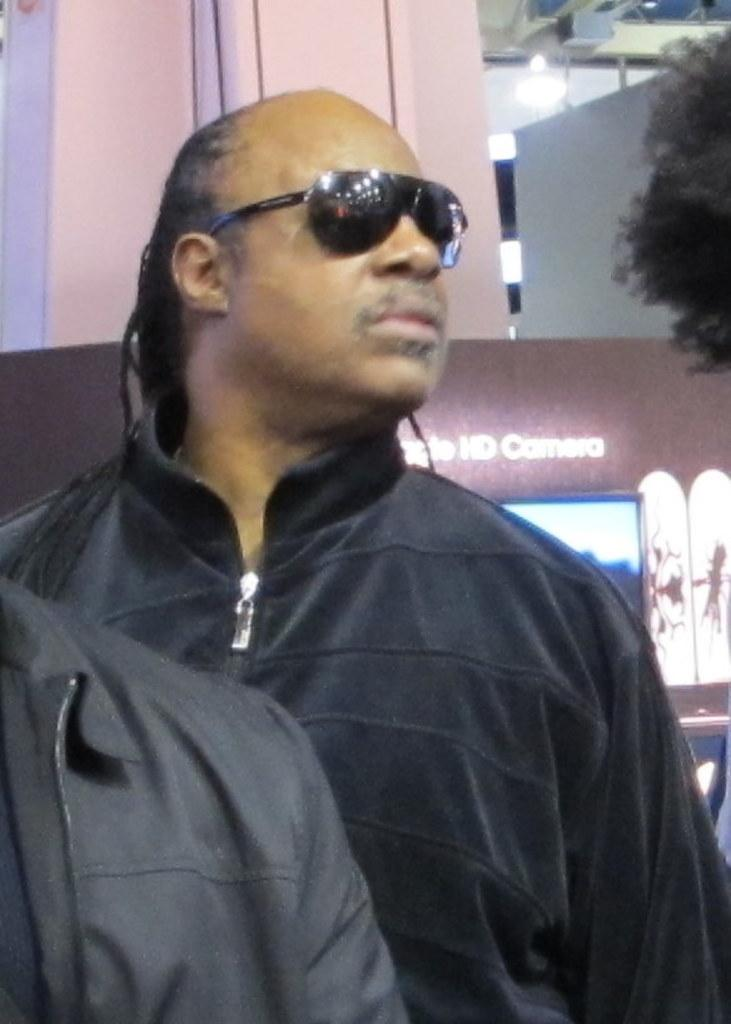Who can be seen in the image? There are people in the image. Can you describe the appearance of one of the individuals? A man is wearing spectacles. What can be seen in the distance behind the people? There is a building, lights, and a tree visible in the background of the image. What type of pleasure can be seen being enjoyed by the people in the image? There is no indication of pleasure or any specific activity being enjoyed by the people in the image. --- Facts: 1. There is a car in the image. 2. The car is red. 3. The car has four wheels. 4. There are people in the car. 5. The car is parked on the street. Absurd Topics: parrot, ocean, dance Conversation: What is the main subject of the image? The main subject of the image is a car. Can you describe the appearance of the car? The car is red and has four wheels. Who or what can be seen inside the car? There are people in the car. Where is the car located in the image? The car is parked on the street. Reasoning: Let's think step by step in order to produce the conversation. We start by identifying the main subject of the image, which is the car. Then, we describe the appearance of the car, including its color and the number of wheels. Next, we mention the presence of people inside the car. Finally, we describe the location of the car, which is parked on the street. Absurd Question/Answer: Can you tell me how many parrots are sitting on the car in the image? There are no parrots present in the image; it features a red car with people inside. What type of dance is being performed by the people in the car? There is no indication of dancing or any specific activity being performed by the people in the car. --- Facts: 1. There is a dog in the image. 2. The dog is brown. 3. The dog is sitting on a mat. 4. There is a bowl of water next to the mat. 5. The background of the image is green. Absurd Topics: bicycle, rainbow, book Conversation: What animal can be seen in the image? There is a dog in the image. Can you describe the appearance of the dog? The dog is brown. Where is the dog located in the image? The dog is sitting on a mat. What is located next to the mat? The dog There is a bowl of water next to the mat. What color is the background of the image? The background of the image is green. Reasoning: Let's think step by step in order to produce the conversation. We start by identifying the main subject of the image, which is the dog. Then, we describe the appearance 